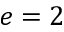<formula> <loc_0><loc_0><loc_500><loc_500>e = 2</formula> 